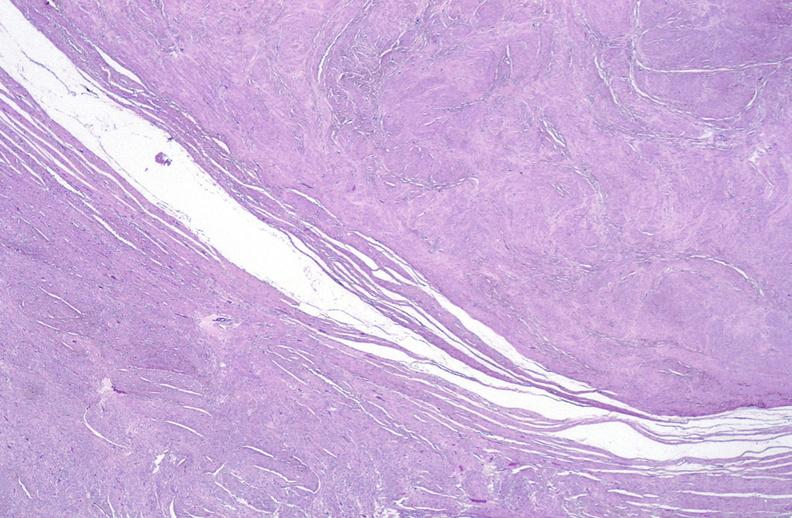s cytomegalovirus present?
Answer the question using a single word or phrase. No 